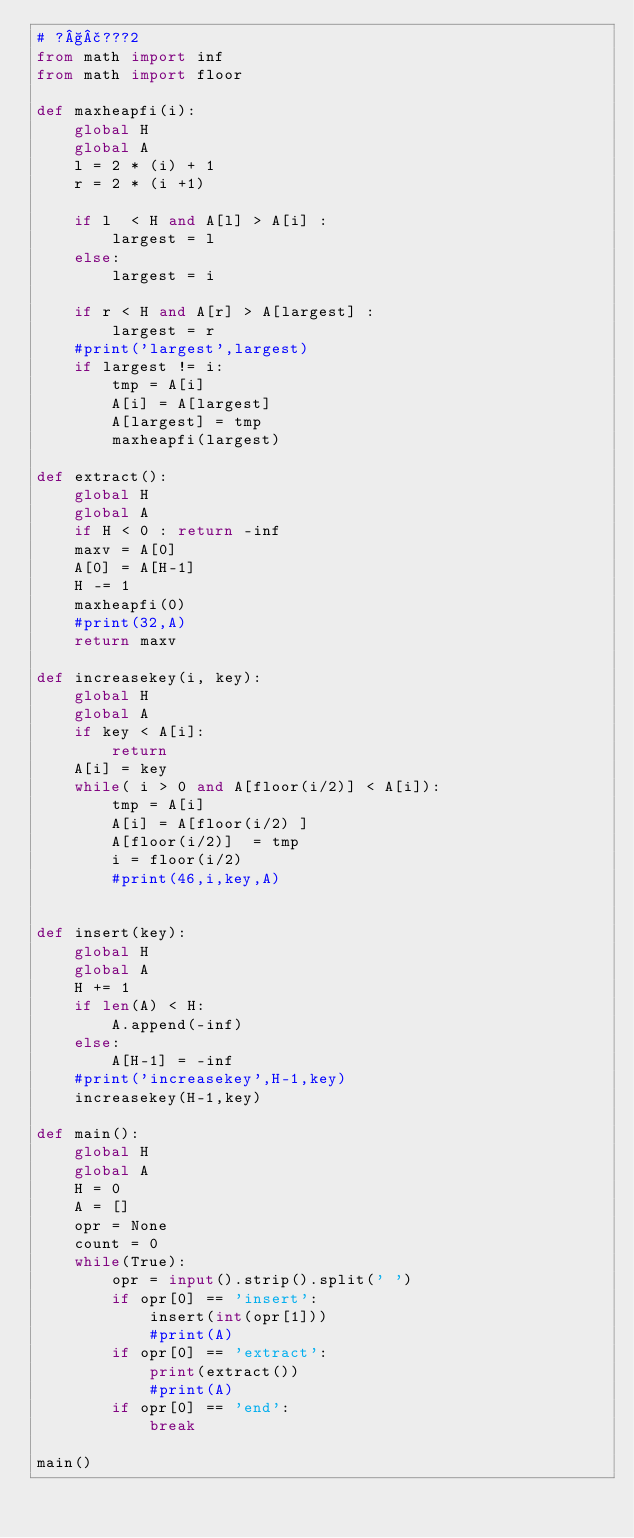<code> <loc_0><loc_0><loc_500><loc_500><_Python_># ?§£???2
from math import inf
from math import floor

def maxheapfi(i):
    global H
    global A
    l = 2 * (i) + 1  
    r = 2 * (i +1)

    if l  < H and A[l] > A[i] :
        largest = l
    else:
        largest = i

    if r < H and A[r] > A[largest] :
        largest = r
    #print('largest',largest)
    if largest != i:
        tmp = A[i]
        A[i] = A[largest]
        A[largest] = tmp
        maxheapfi(largest)
    
def extract():
    global H
    global A
    if H < 0 : return -inf
    maxv = A[0]
    A[0] = A[H-1]
    H -= 1
    maxheapfi(0)
    #print(32,A)
    return maxv

def increasekey(i, key):
    global H
    global A
    if key < A[i]:
        return
    A[i] = key
    while( i > 0 and A[floor(i/2)] < A[i]):
        tmp = A[i]
        A[i] = A[floor(i/2) ] 
        A[floor(i/2)]  = tmp
        i = floor(i/2)
        #print(46,i,key,A)
    
        
def insert(key):
    global H
    global A
    H += 1
    if len(A) < H:
        A.append(-inf)
    else:
        A[H-1] = -inf
    #print('increasekey',H-1,key)
    increasekey(H-1,key)

def main():
    global H
    global A
    H = 0
    A = []
    opr = None
    count = 0
    while(True):
        opr = input().strip().split(' ')
        if opr[0] == 'insert':
            insert(int(opr[1]))
            #print(A)
        if opr[0] == 'extract':
            print(extract())
            #print(A)
        if opr[0] == 'end':
            break
        
main()</code> 